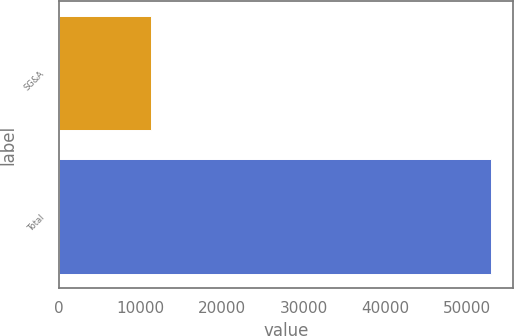Convert chart. <chart><loc_0><loc_0><loc_500><loc_500><bar_chart><fcel>SG&A<fcel>Total<nl><fcel>11234<fcel>52932<nl></chart> 